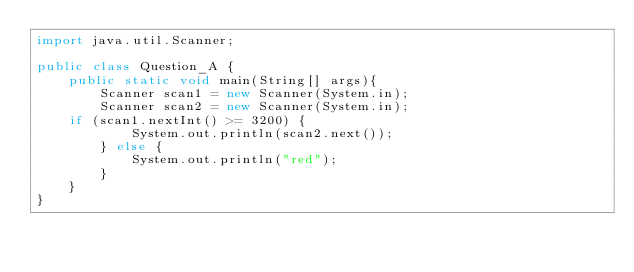<code> <loc_0><loc_0><loc_500><loc_500><_Java_>import java.util.Scanner;

public class Question_A {
	public static void main(String[] args){
		Scanner scan1 = new Scanner(System.in);
		Scanner scan2 = new Scanner(System.in);
	if (scan1.nextInt() >= 3200) {
			System.out.println(scan2.next());
		} else {
			System.out.println("red");
		}
	}
}
</code> 